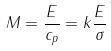Convert formula to latex. <formula><loc_0><loc_0><loc_500><loc_500>M = \frac { E } { c _ { p } } = k \frac { E } { \sigma }</formula> 